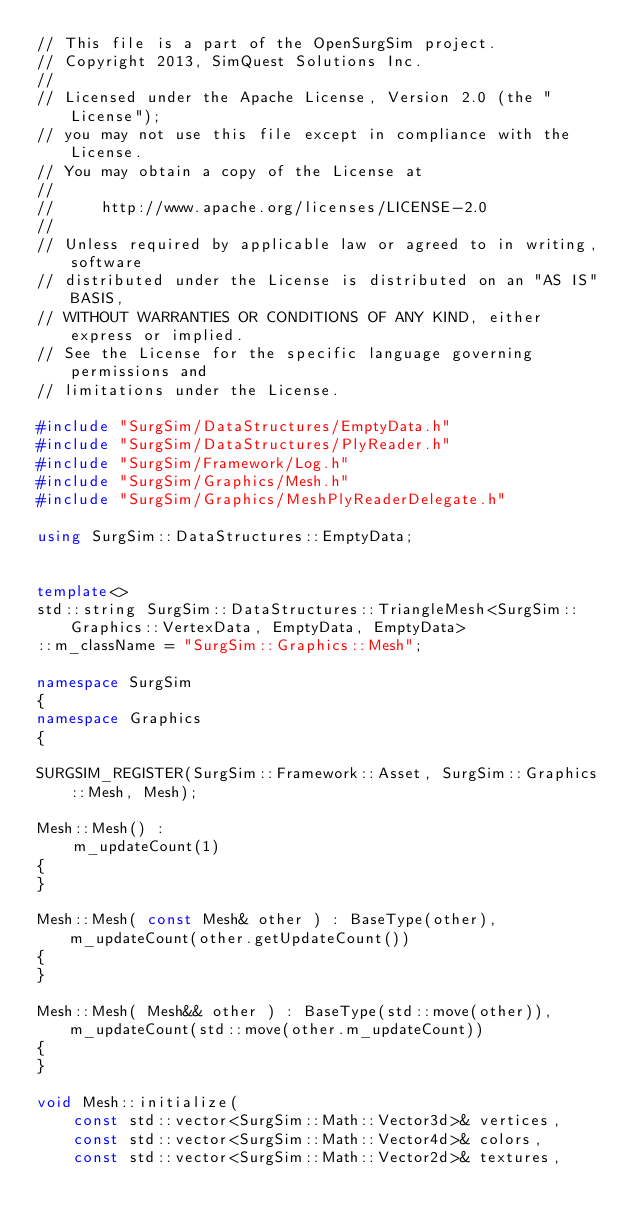<code> <loc_0><loc_0><loc_500><loc_500><_C++_>// This file is a part of the OpenSurgSim project.
// Copyright 2013, SimQuest Solutions Inc.
//
// Licensed under the Apache License, Version 2.0 (the "License");
// you may not use this file except in compliance with the License.
// You may obtain a copy of the License at
//
//     http://www.apache.org/licenses/LICENSE-2.0
//
// Unless required by applicable law or agreed to in writing, software
// distributed under the License is distributed on an "AS IS" BASIS,
// WITHOUT WARRANTIES OR CONDITIONS OF ANY KIND, either express or implied.
// See the License for the specific language governing permissions and
// limitations under the License.

#include "SurgSim/DataStructures/EmptyData.h"
#include "SurgSim/DataStructures/PlyReader.h"
#include "SurgSim/Framework/Log.h"
#include "SurgSim/Graphics/Mesh.h"
#include "SurgSim/Graphics/MeshPlyReaderDelegate.h"

using SurgSim::DataStructures::EmptyData;


template<>
std::string SurgSim::DataStructures::TriangleMesh<SurgSim::Graphics::VertexData, EmptyData, EmptyData>
::m_className = "SurgSim::Graphics::Mesh";

namespace SurgSim
{
namespace Graphics
{

SURGSIM_REGISTER(SurgSim::Framework::Asset, SurgSim::Graphics::Mesh, Mesh);

Mesh::Mesh() :
	m_updateCount(1)
{
}

Mesh::Mesh( const Mesh& other ) : BaseType(other), m_updateCount(other.getUpdateCount())
{
}

Mesh::Mesh( Mesh&& other ) : BaseType(std::move(other)), m_updateCount(std::move(other.m_updateCount))
{
}

void Mesh::initialize(
	const std::vector<SurgSim::Math::Vector3d>& vertices,
	const std::vector<SurgSim::Math::Vector4d>& colors,
	const std::vector<SurgSim::Math::Vector2d>& textures,</code> 